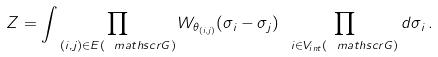Convert formula to latex. <formula><loc_0><loc_0><loc_500><loc_500>Z = \int \prod _ { ( i , j ) \in E ( { \ m a t h s c r G } ) } W _ { \theta _ { ( i , j ) } } ( \sigma _ { i } - \sigma _ { j } ) \ \prod _ { i \in V _ { i n t } ( { \ m a t h s c r G } ) } d \sigma _ { i } \, .</formula> 